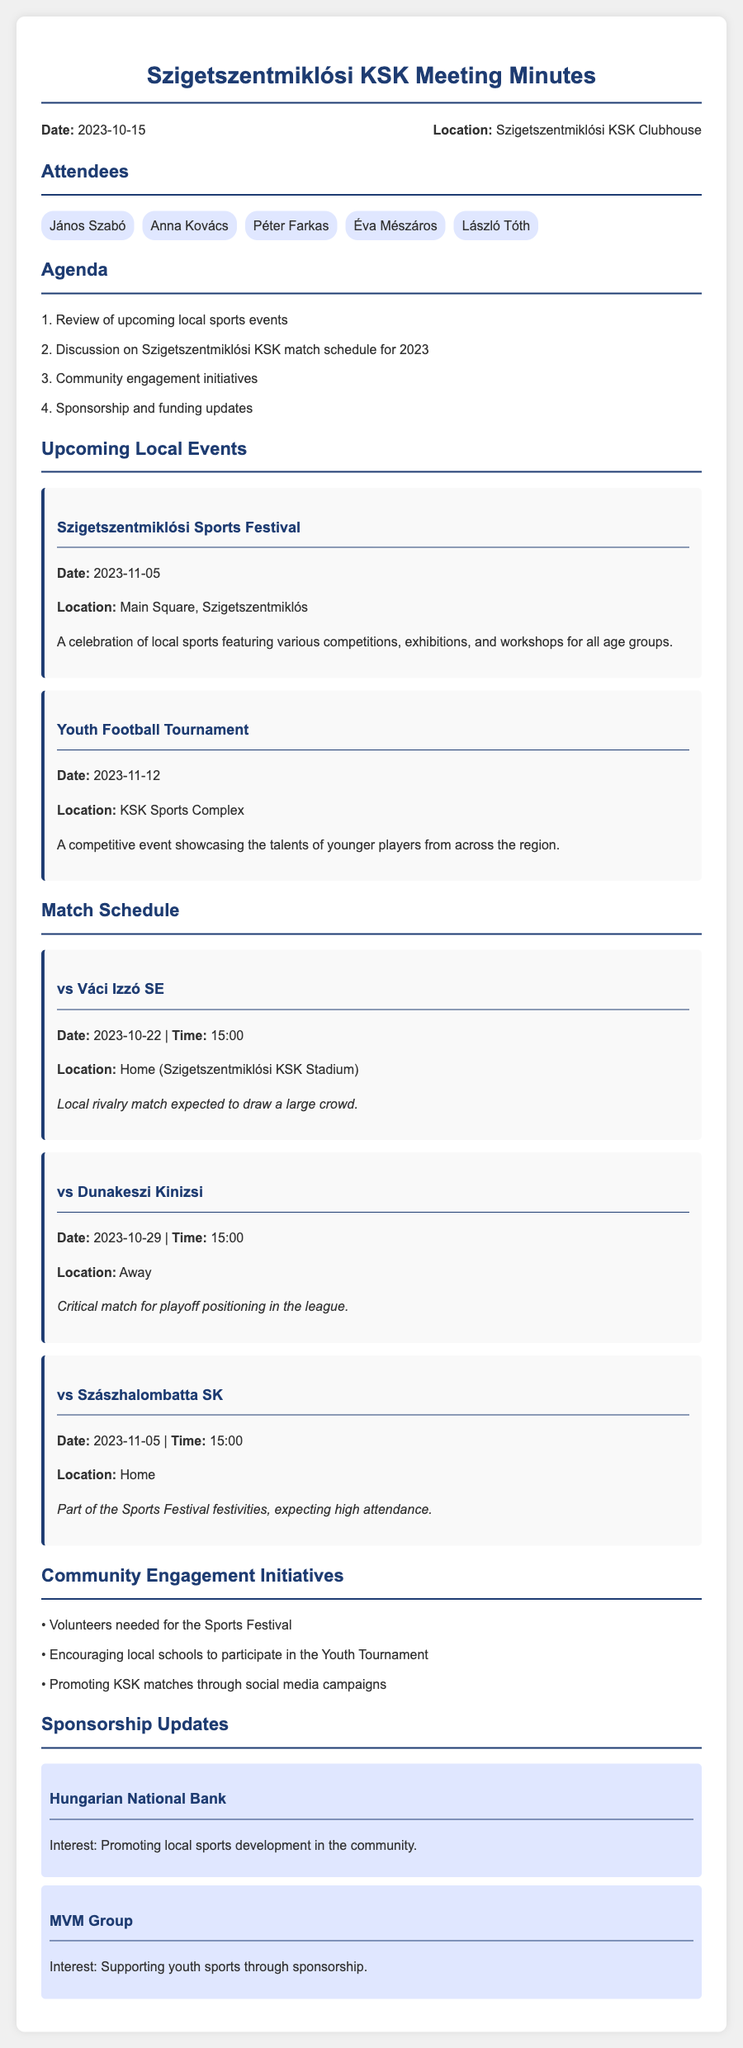What is the date of the meeting? The meeting date is explicitly mentioned in the document.
Answer: 2023-10-15 Where is the Szigetszentmiklósi KSK Clubhouse located? The location of the meeting is provided in the header section.
Answer: Szigetszentmiklósi KSK Clubhouse What is the first event listed under upcoming local events? The first event mentioned in the document highlights an upcoming local sports festival.
Answer: Szigetszentmiklósi Sports Festival When is the match against Váci Izzó SE scheduled? The match schedule provides specific dates and times for upcoming matches.
Answer: 2023-10-22 Which sponsor is interested in promoting local sports development? The document lists sponsors and their interests, highlighting contributions to community sports.
Answer: Hungarian National Bank What initiative involves local schools? The community engagement initiatives include various activities to enhance involvement.
Answer: Encouraging local schools to participate in the Youth Tournament How many matches are scheduled for Szigetszentmiklósi KSK in November 2023? By reviewing the match schedule, we can count the matches occurring in November.
Answer: 2 What is the time for the match on October 29, 2023? The match schedule indicates specific times for each match listed.
Answer: 15:00 What type of event is the Youth Football Tournament? The description of the event indicates the nature of the competition.
Answer: A competitive event showcasing the talents of younger players 